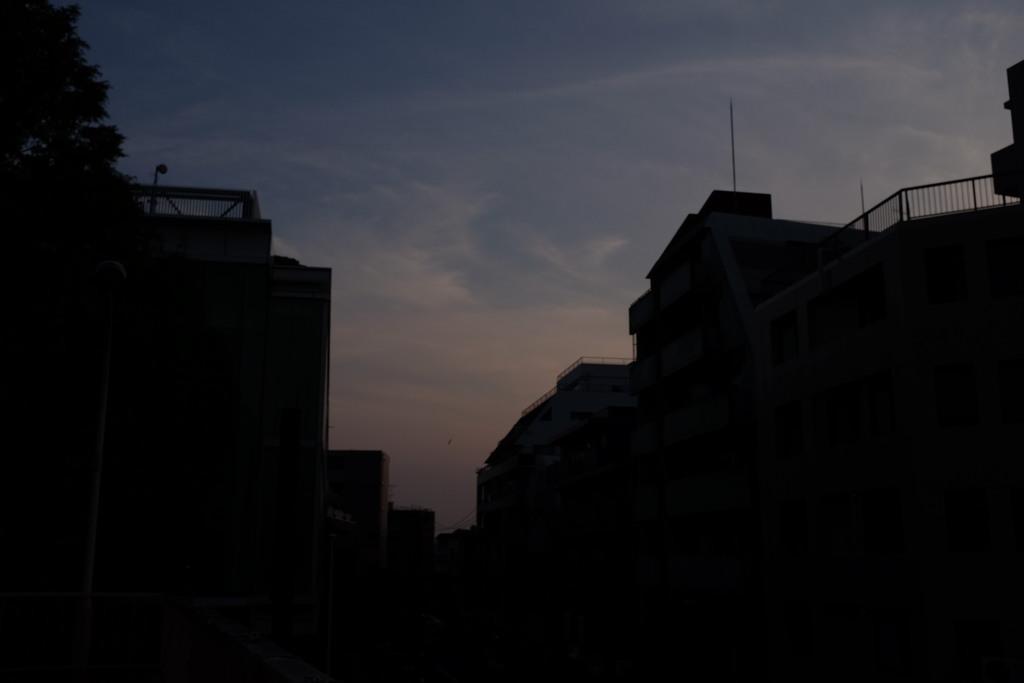How would you summarize this image in a sentence or two? In the picture I can see buildings, a tree and fence. In the background I can see the sky. The image is little bit dark. 